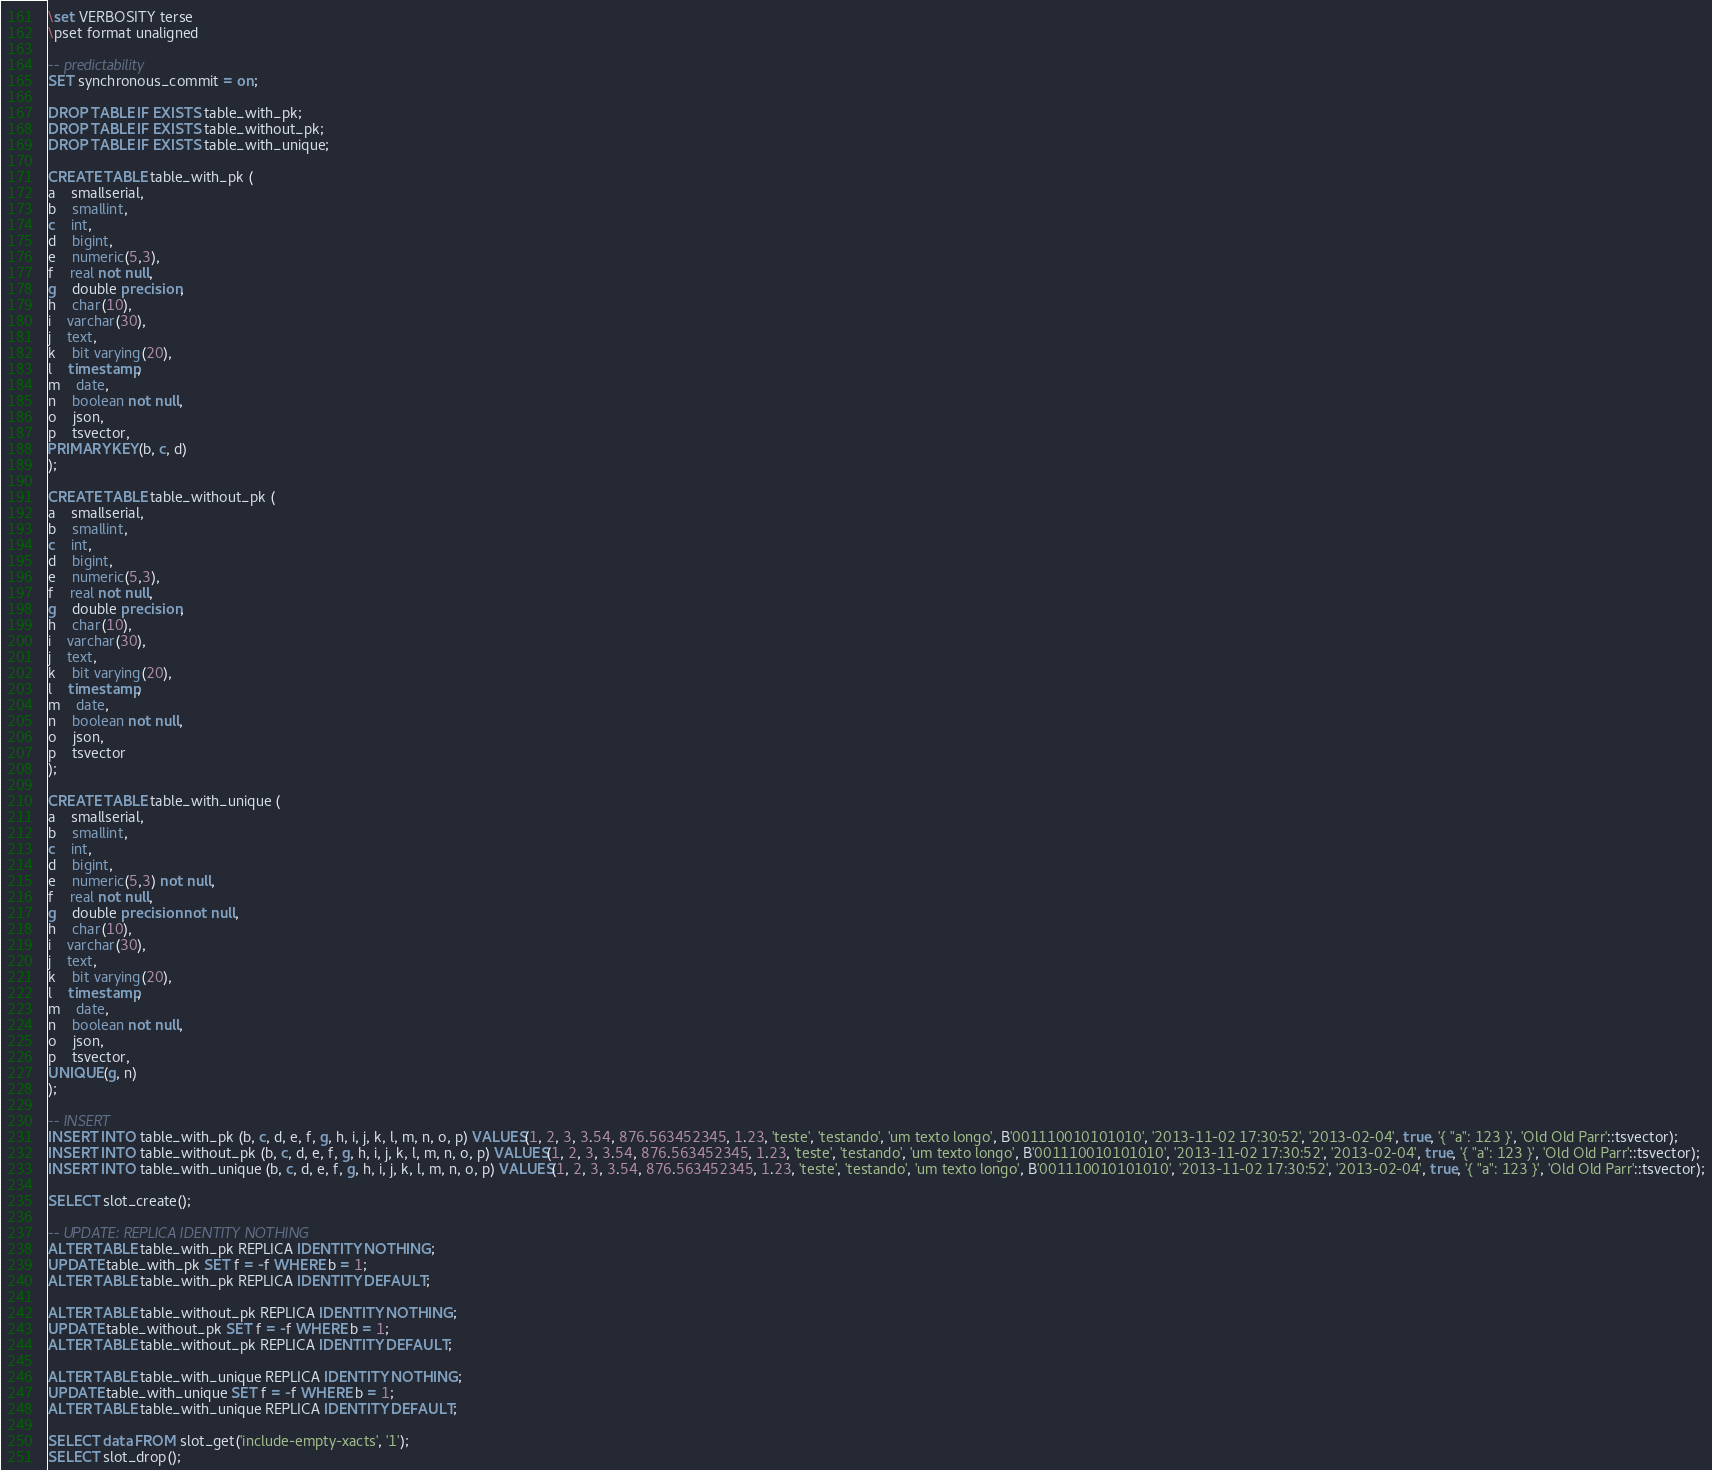<code> <loc_0><loc_0><loc_500><loc_500><_SQL_>\set VERBOSITY terse
\pset format unaligned

-- predictability
SET synchronous_commit = on;

DROP TABLE IF EXISTS table_with_pk;
DROP TABLE IF EXISTS table_without_pk;
DROP TABLE IF EXISTS table_with_unique;

CREATE TABLE table_with_pk (
a	smallserial,
b	smallint,
c	int,
d	bigint,
e	numeric(5,3),
f	real not null,
g	double precision,
h	char(10),
i	varchar(30),
j	text,
k	bit varying(20),
l	timestamp,
m	date,
n	boolean not null,
o	json,
p	tsvector,
PRIMARY KEY(b, c, d)
);

CREATE TABLE table_without_pk (
a	smallserial,
b	smallint,
c	int,
d	bigint,
e	numeric(5,3),
f	real not null,
g	double precision,
h	char(10),
i	varchar(30),
j	text,
k	bit varying(20),
l	timestamp,
m	date,
n	boolean not null,
o	json,
p	tsvector
);

CREATE TABLE table_with_unique (
a	smallserial,
b	smallint,
c	int,
d	bigint,
e	numeric(5,3) not null,
f	real not null,
g	double precision not null,
h	char(10),
i	varchar(30),
j	text,
k	bit varying(20),
l	timestamp,
m	date,
n	boolean not null,
o	json,
p	tsvector,
UNIQUE(g, n)
);

-- INSERT
INSERT INTO table_with_pk (b, c, d, e, f, g, h, i, j, k, l, m, n, o, p) VALUES(1, 2, 3, 3.54, 876.563452345, 1.23, 'teste', 'testando', 'um texto longo', B'001110010101010', '2013-11-02 17:30:52', '2013-02-04', true, '{ "a": 123 }', 'Old Old Parr'::tsvector);
INSERT INTO table_without_pk (b, c, d, e, f, g, h, i, j, k, l, m, n, o, p) VALUES(1, 2, 3, 3.54, 876.563452345, 1.23, 'teste', 'testando', 'um texto longo', B'001110010101010', '2013-11-02 17:30:52', '2013-02-04', true, '{ "a": 123 }', 'Old Old Parr'::tsvector);
INSERT INTO table_with_unique (b, c, d, e, f, g, h, i, j, k, l, m, n, o, p) VALUES(1, 2, 3, 3.54, 876.563452345, 1.23, 'teste', 'testando', 'um texto longo', B'001110010101010', '2013-11-02 17:30:52', '2013-02-04', true, '{ "a": 123 }', 'Old Old Parr'::tsvector);

SELECT slot_create();

-- UPDATE: REPLICA IDENTITY NOTHING
ALTER TABLE table_with_pk REPLICA IDENTITY NOTHING;
UPDATE table_with_pk SET f = -f WHERE b = 1;
ALTER TABLE table_with_pk REPLICA IDENTITY DEFAULT;

ALTER TABLE table_without_pk REPLICA IDENTITY NOTHING;
UPDATE table_without_pk SET f = -f WHERE b = 1;
ALTER TABLE table_without_pk REPLICA IDENTITY DEFAULT;

ALTER TABLE table_with_unique REPLICA IDENTITY NOTHING;
UPDATE table_with_unique SET f = -f WHERE b = 1;
ALTER TABLE table_with_unique REPLICA IDENTITY DEFAULT;

SELECT data FROM slot_get('include-empty-xacts', '1');
SELECT slot_drop();
</code> 